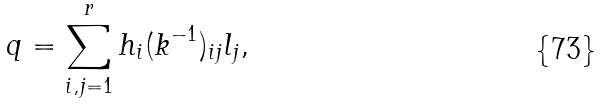Convert formula to latex. <formula><loc_0><loc_0><loc_500><loc_500>q = \sum _ { i , j = 1 } ^ { r } h _ { i } ( k ^ { - 1 } ) _ { i j } l _ { j } ,</formula> 